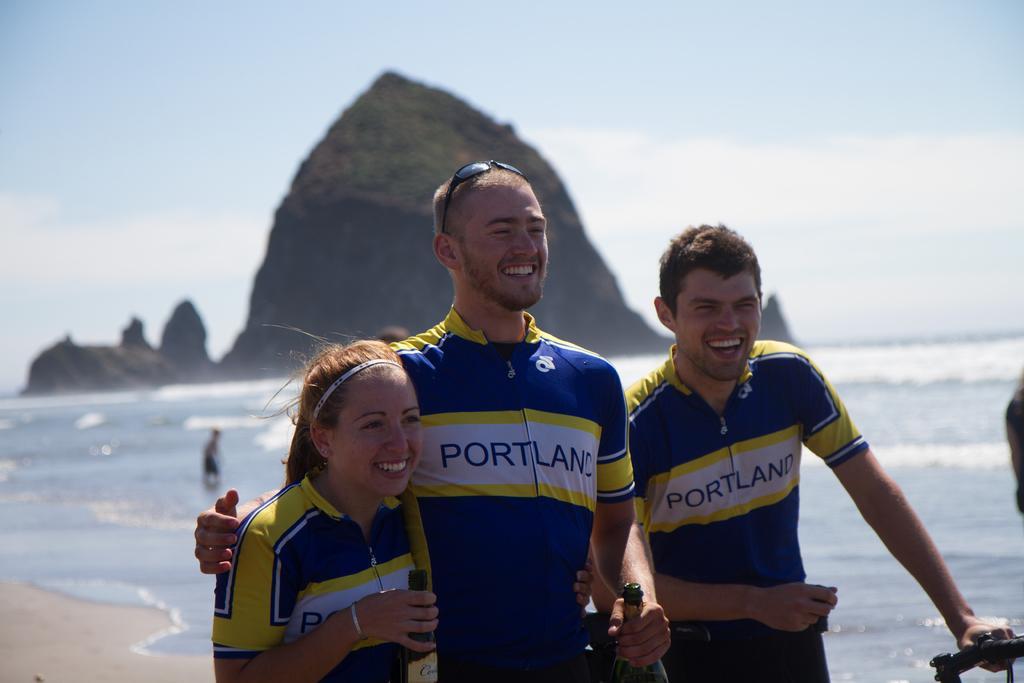Can you describe this image briefly? In the middle of the image few people are standing and holding bottles and smiling. Behind them there is water and hill. Top of the image there are some clouds and sky. 